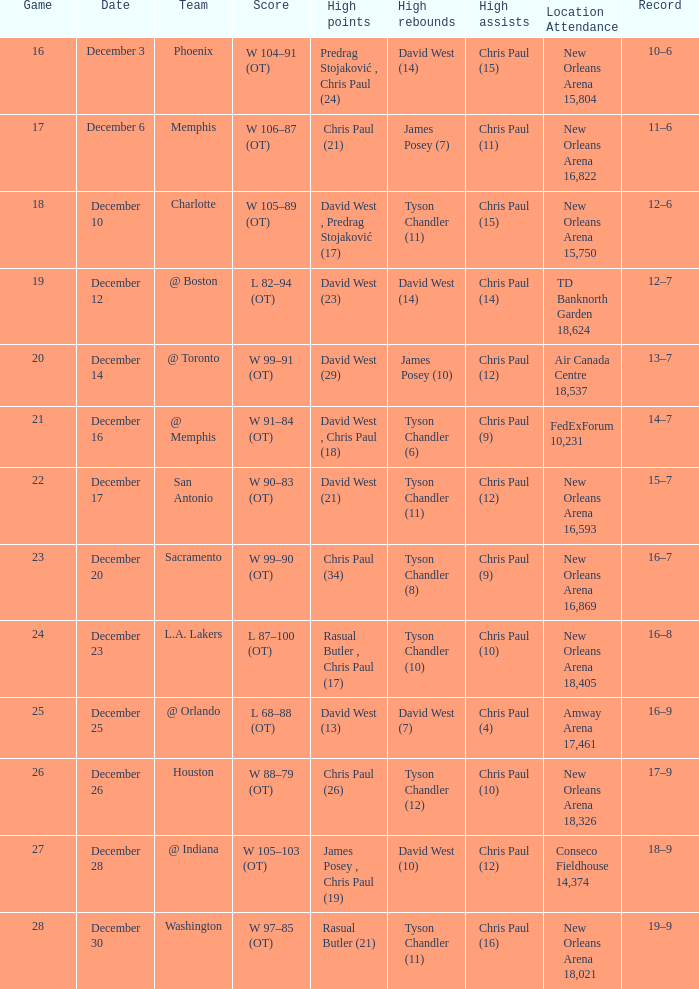What is Record, when High Rebounds is "Tyson Chandler (6)"? 14–7. 